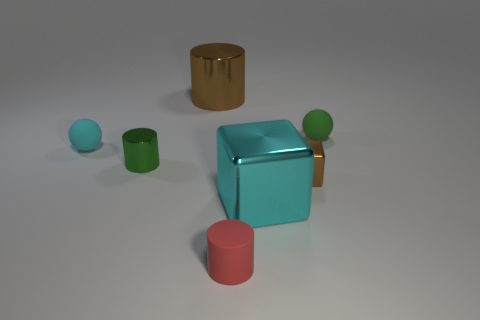Are there any big things?
Your response must be concise. Yes. What is the shape of the big metal thing that is to the right of the tiny thing that is in front of the cyan cube?
Your answer should be compact. Cube. How many objects are balls that are on the right side of the large brown metal cylinder or big things behind the big cyan metallic block?
Your answer should be very brief. 2. There is a brown thing that is the same size as the green rubber ball; what is its material?
Offer a terse response. Metal. What color is the small matte cylinder?
Keep it short and to the point. Red. The tiny thing that is both behind the tiny green metal cylinder and left of the large brown cylinder is made of what material?
Make the answer very short. Rubber. There is a big metallic thing that is on the left side of the red rubber cylinder that is in front of the cyan metallic cube; are there any small brown objects that are left of it?
Your response must be concise. No. The shiny thing that is the same color as the tiny metallic cube is what size?
Make the answer very short. Large. Are there any tiny matte spheres left of the big brown metal object?
Your response must be concise. Yes. How many other things are the same shape as the small green shiny thing?
Offer a very short reply. 2. 